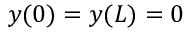Convert formula to latex. <formula><loc_0><loc_0><loc_500><loc_500>y ( 0 ) = y ( L ) = 0</formula> 